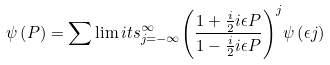Convert formula to latex. <formula><loc_0><loc_0><loc_500><loc_500>\psi \left ( { P } \right ) = \sum \lim i t s _ { j = - \infty } ^ { \infty } { \left ( { { \frac { 1 + { \frac { i } { 2 } } i \epsilon P } { 1 - { \frac { i } { 2 } } i \epsilon P } } } \right ) } ^ { j } \psi \left ( { \epsilon j } \right )</formula> 